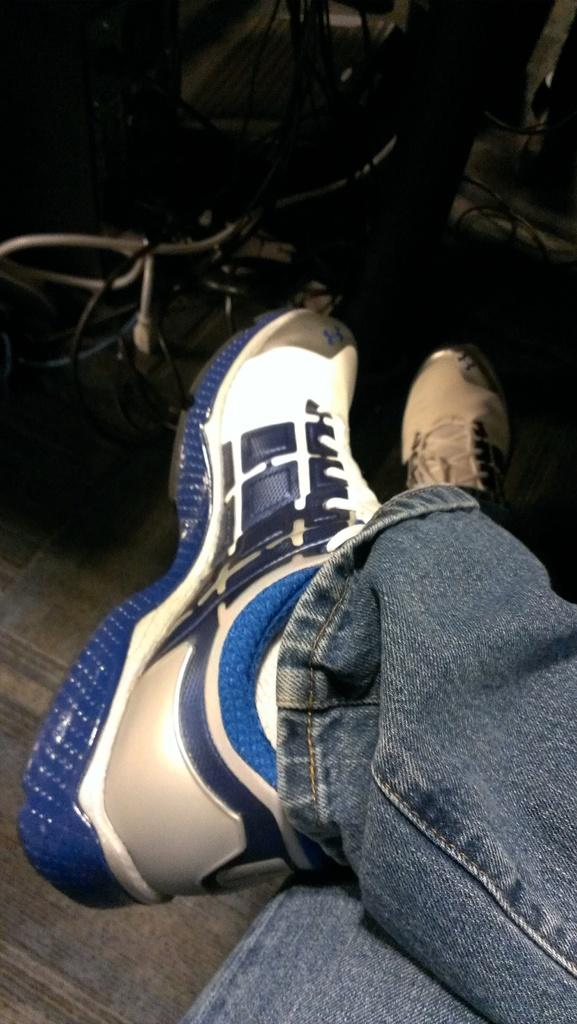What body parts are visible in the image? There are human legs visible in the image. What type of footwear is the person wearing? There are shoes in the image. What type of clothing is the person wearing on their legs? The person is wearing jeans trousers. What type of camera is the person using in the image? There is no camera present in the image; only human legs, shoes, and jeans trousers are visible. 